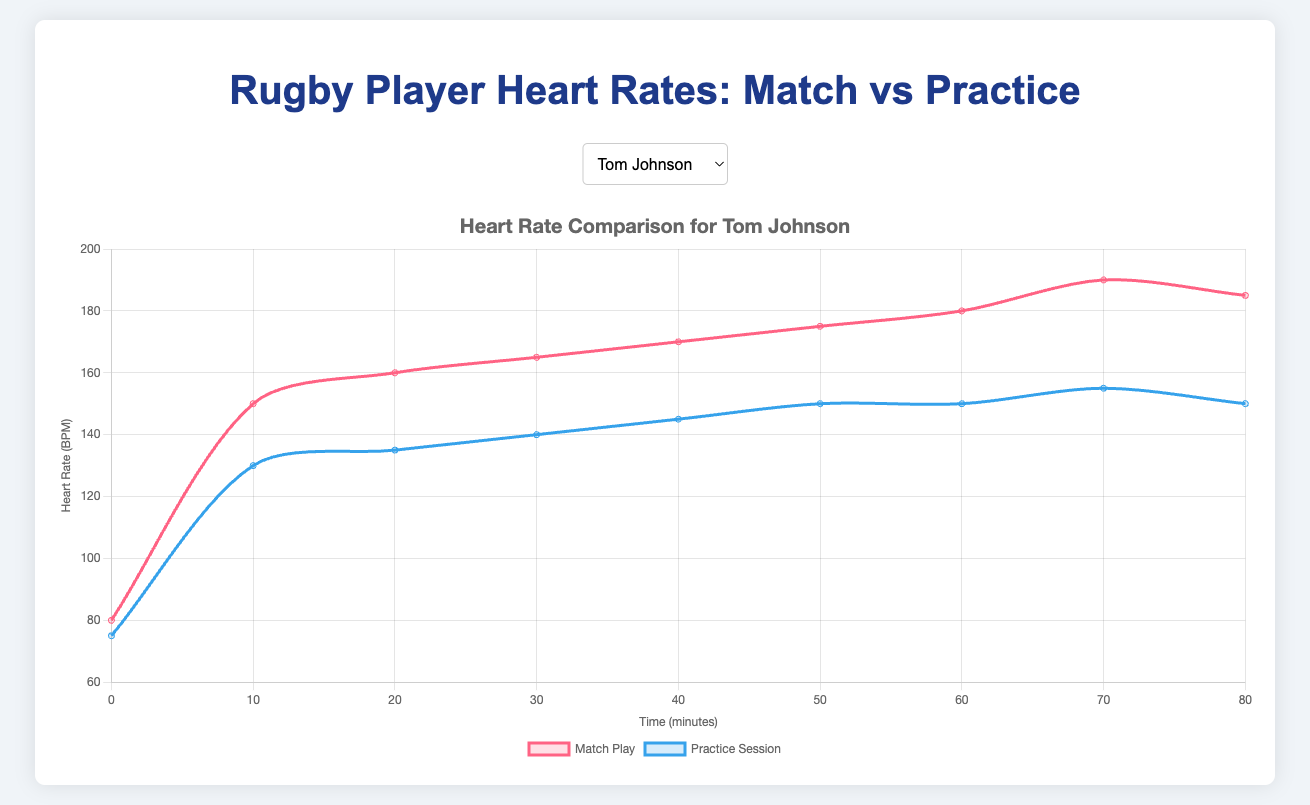What is Tom Johnson's highest heart rate during match play? Looking at the match play curve for Tom Johnson, the highest peak is at 190 BPM.
Answer: 190 BPM Compare the heart rate of Alex Hepburn at 30 minutes during match play and practice session. Which is higher and by how much? Alex Hepburn’s heart rate at 30 minutes during match play (160 BPM) is higher than during the practice session (135 BPM). The difference is 160 - 135 = 25 BPM.
Answer: Match play is higher by 25 BPM Which player has the highest heart rate during a practice session at 50 minutes? By inspecting the curves for the practice sessions of all players at the 50-minute mark, Harry Williams has the highest heart rate at 155 BPM.
Answer: Harry Williams What is the average heart rate of Don Armand from 20 to 40 minutes during match play? Sum the heart rates of Don Armand at 20 (165 BPM), 30 (170 BPM), and 40 (175 BPM) minutes: 165 + 170 + 175 = 510. Divide by the number of values (3): 510 / 3 = 170.
Answer: 170 BPM For Ian Whitten, what is the difference in heart rate between match play and practice session at 70 minutes? At 70 minutes, Ian Whitten's heart rate during match play is 180 BPM and during the practice session is 150 BPM. The difference is 180 - 150 = 30 BPM.
Answer: 30 BPM Which player shows the greatest increase in heart rate from the start (0 minutes) to the end (80 minutes) of match play? Calculate the difference for each player:
Tom Johnson: 185 - 80 = 105
Alex Hepburn: 170 - 78 = 92
Don Armand: 180 - 82 = 98
Ian Whitten: 175 - 80 = 95
Harry Williams: 190 - 85 = 105. 
Both Tom Johnson and Harry Williams show the greatest increase of 105 BPM.
Answer: Tom Johnson and Harry Williams Who had a higher heart rate at 60 minutes during match play, Don Armand or Ian Whitten? Don Armand’s heart rate at 60 minutes during match play is 185 BPM, while Ian Whitten's is 175 BPM.
Answer: Don Armand During the practice session, which player had the most consistent heart rate (smallest variation) between 10 and 60 minutes? Calculate the range (max heart rate - min heart rate) for each player from 10 to 60 minutes. The player with the smallest range is the most consistent:
Tom Johnson: max 150 - min 130 = 20
Alex Hepburn: max 145 - min 120 = 25
Don Armand: max 155 - min 130 = 25
Ian Whitten: max 145 - min 125 = 20
Harry Williams: max 155 - min 135 = 20. 
Tom Johnson, Ian Whitten, and Harry Williams all have the smallest range of 20 BPM.
Answer: Tom Johnson, Ian Whitten, and Harry Williams 